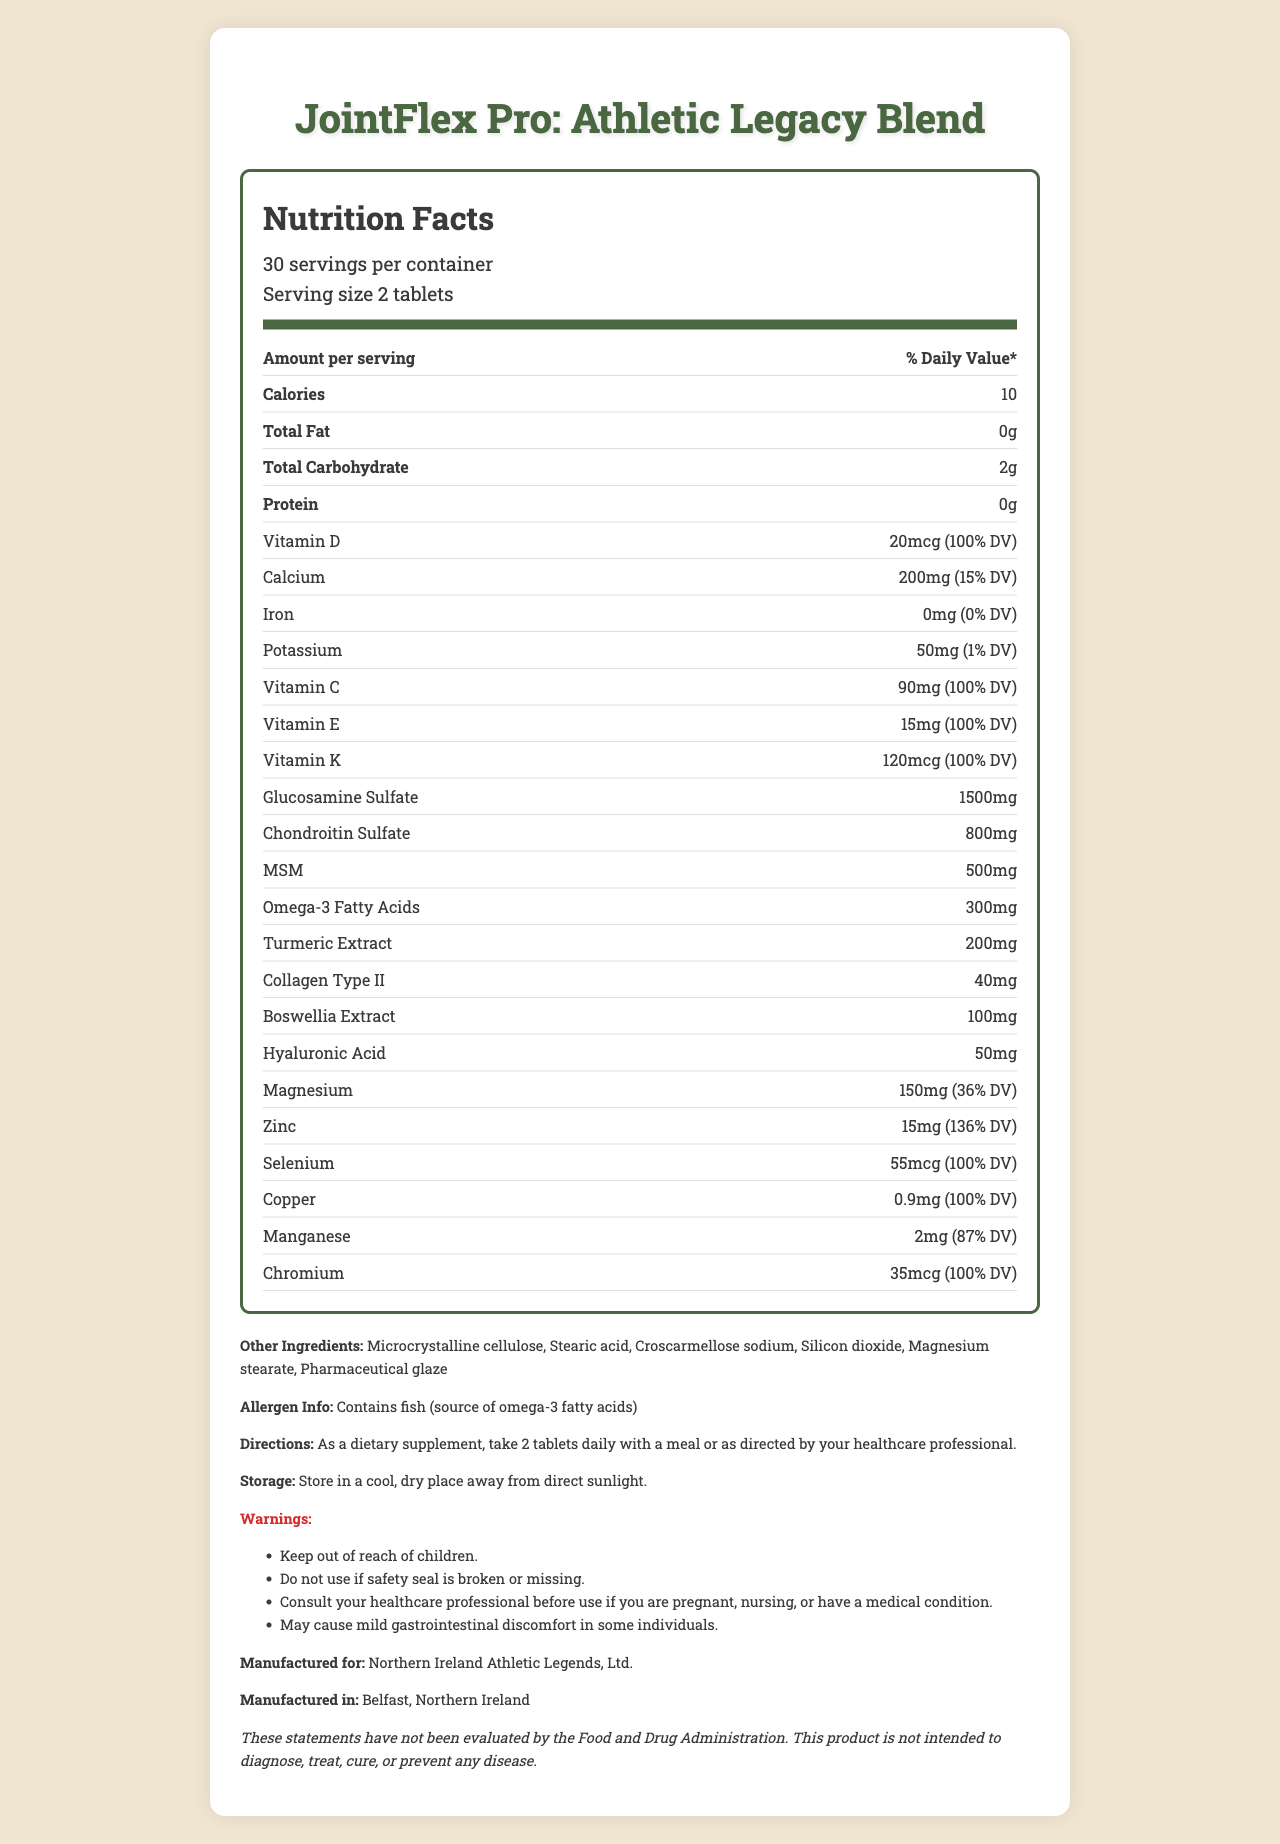what is the serving size? The serving size is explicitly mentioned as "2 tablets."
Answer: 2 tablets how many calories are there per serving? The document states that each serving contains 10 calories.
Answer: 10 which minerals are included in the supplement? The minerals listed are Calcium (200mg), Potassium (50mg), Magnesium (150mg), Zinc (15mg), Selenium (55mcg), Copper (0.9mg), Manganese (2mg), and Chromium (35mcg).
Answer: Calcium, Potassium, Magnesium, Zinc, Selenium, Copper, Manganese, Chromium how many servings are in one container? The document states that there are 30 servings per container.
Answer: 30 does this product contain any protein? The document shows that the protein content is 0g.
Answer: No what percent Daily Value (DV) of Vitamin D does each serving provide? A. 50% B. 75% C. 100% D. 150% The document states that each serving provides 20mcg of Vitamin D, which is 100% of the Daily Value (DV).
Answer: C which ingredient is included in the highest amount per serving? A. Glucosamine Sulfate B. Chondroitin Sulfate C. MSM D. Omega-3 Fatty Acids The document indicates that Glucosamine Sulfate is present at 1500mg per serving, the highest amount among the listed options.
Answer: A does this supplement contain fish allergens? The document mentions that the product contains fish, a source of omega-3 fatty acids.
Answer: Yes summarize the main purpose of this document. The document describes the nutritional components and directions for using the "JointFlex Pro: Athletic Legacy Blend" supplement, emphasizing its purpose to support joint health and muscle maintenance. It provides specific details on vitamins, minerals, and other active ingredients, along with usage and safety instructions.
Answer: The document provides detailed nutrition facts and ingredient information for the vitamin supplement "JointFlex Pro: Athletic Legacy Blend," specifically designed to help maintain joint health and muscle mass in aging former athletes. It includes serving details, nutritional content, directions for use, storage instructions, allergen information, and warnings. who is this supplement manufactured for? The document states the supplement is manufactured for Northern Ireland Athletic Legends, Ltd.
Answer: Northern Ireland Athletic Legends, Ltd. how many milligrams of omega-3 fatty acids are in each serving? The document lists 300mg of omega-3 fatty acids per serving.
Answer: 300mg what is the amount of glucosamine sulfate per serving? The document mentions that each serving contains 1500mg of Glucosamine Sulfate.
Answer: 1500mg can this product be used to diagnose, treat, cure, or prevent any disease? The document includes a disclaimer stating that the product is not intended to diagnose, treat, cure, or prevent any disease.
Answer: No what are the recommended storage conditions? The document specifies these conditions for storing the product.
Answer: Store in a cool, dry place away from direct sunlight. does the product include any added sugars? The document does not list any added sugars in the ingredients.
Answer: No where is the product manufactured? The document states that the product is manufactured in Belfast, Northern Ireland.
Answer: Belfast, Northern Ireland what is the warning about gastrointestinal discomfort related to this supplement? The warning section mentions that the supplement may cause mild gastrointestinal discomfort in some individuals.
Answer: May cause mild gastrointestinal discomfort in some individuals. do we know the manufacturing date of the product? The manufacturing date is not provided in the document.
Answer: Cannot be determined 